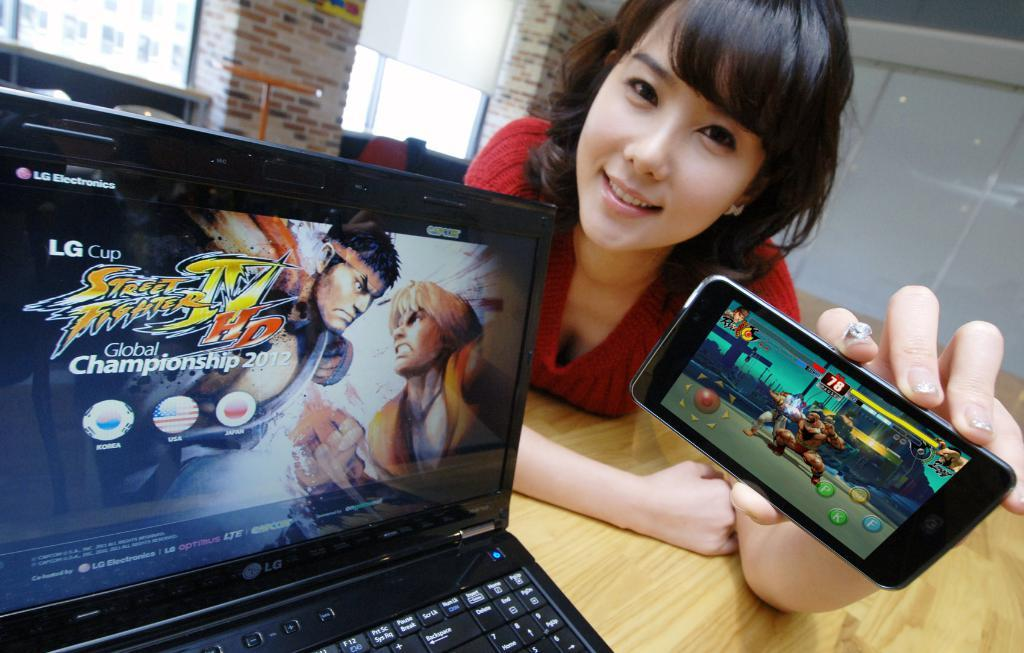Who is present in the image? There is a woman in the image. What is the woman holding in her hand? The woman is holding a mobile in her hand. What can be seen on the table in the image? There is a laptop on the table. What is visible in the background of the image? There is a wall in the image. What type of appliance is attached to the woman's wing in the image? There is no wing or appliance attached to the woman in the image. 